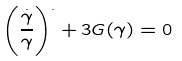<formula> <loc_0><loc_0><loc_500><loc_500>\left ( \frac { \stackrel { . } { \gamma } } { \gamma } \right ) ^ { . } + 3 G ( \gamma ) = 0</formula> 